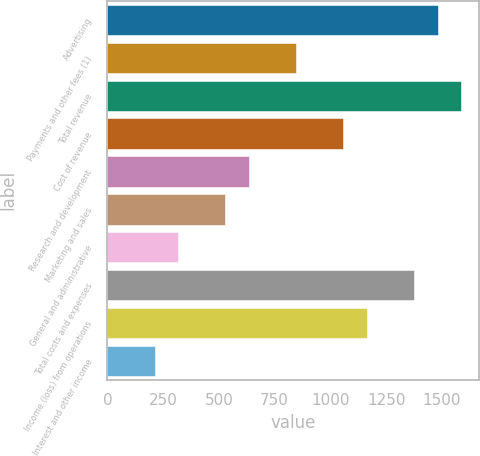<chart> <loc_0><loc_0><loc_500><loc_500><bar_chart><fcel>Advertising<fcel>Payments and other fees (1)<fcel>Total revenue<fcel>Cost of revenue<fcel>Research and development<fcel>Marketing and sales<fcel>General and administrative<fcel>Total costs and expenses<fcel>Income (loss) from operations<fcel>Interest and other income<nl><fcel>1481.15<fcel>846.41<fcel>1586.94<fcel>1057.99<fcel>634.83<fcel>529.04<fcel>317.46<fcel>1375.36<fcel>1163.78<fcel>211.67<nl></chart> 